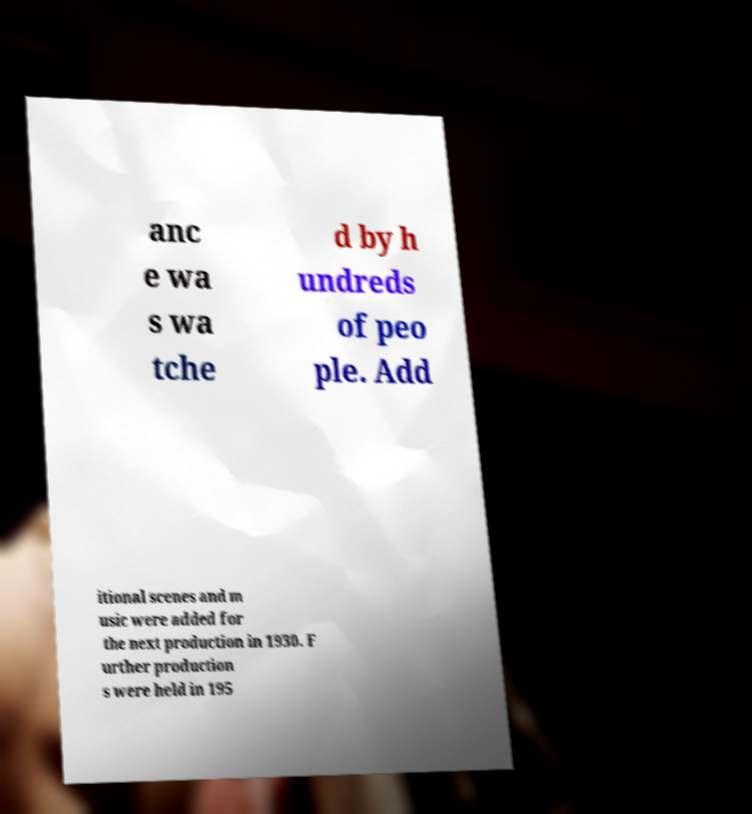I need the written content from this picture converted into text. Can you do that? anc e wa s wa tche d by h undreds of peo ple. Add itional scenes and m usic were added for the next production in 1930. F urther production s were held in 195 